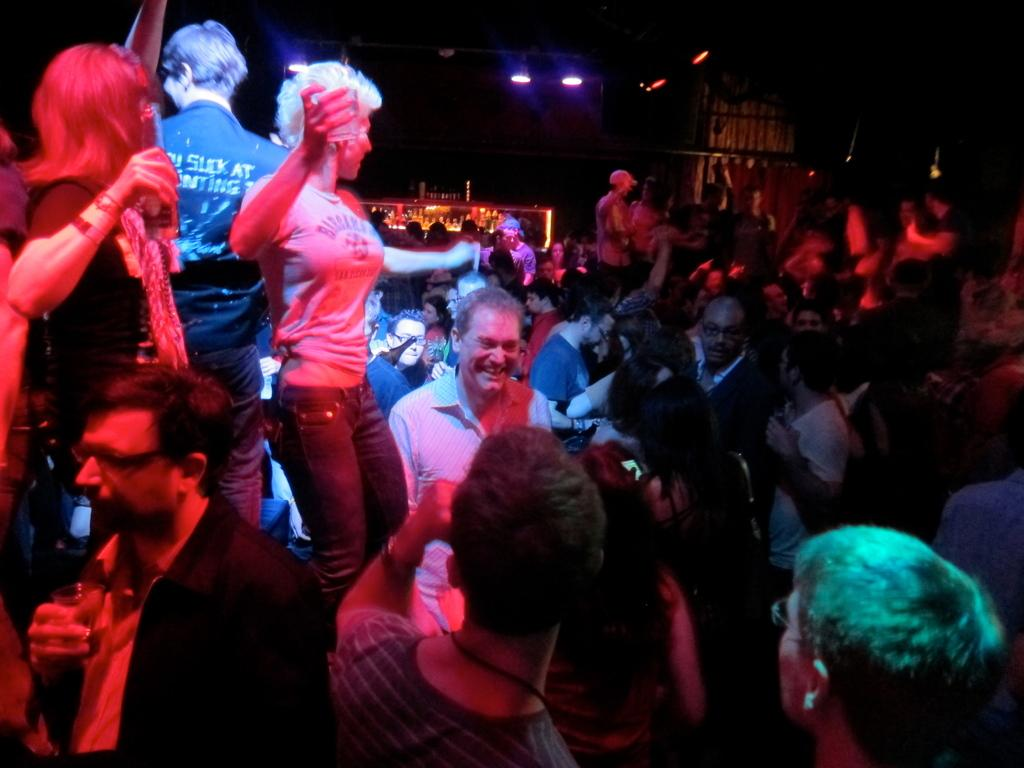How many people are present in the image? There are many people in the image. What are some of the people doing in the image? Some people are dancing, and some people are standing with smiles on their faces. What can be seen in the background of the image? There is a stall in the background of the image. What type of lighting is visible in the image? There are focus lights visible in the image. What type of mitten is being used to plot a course in the image? There is no mitten or plotting activity present in the image. 